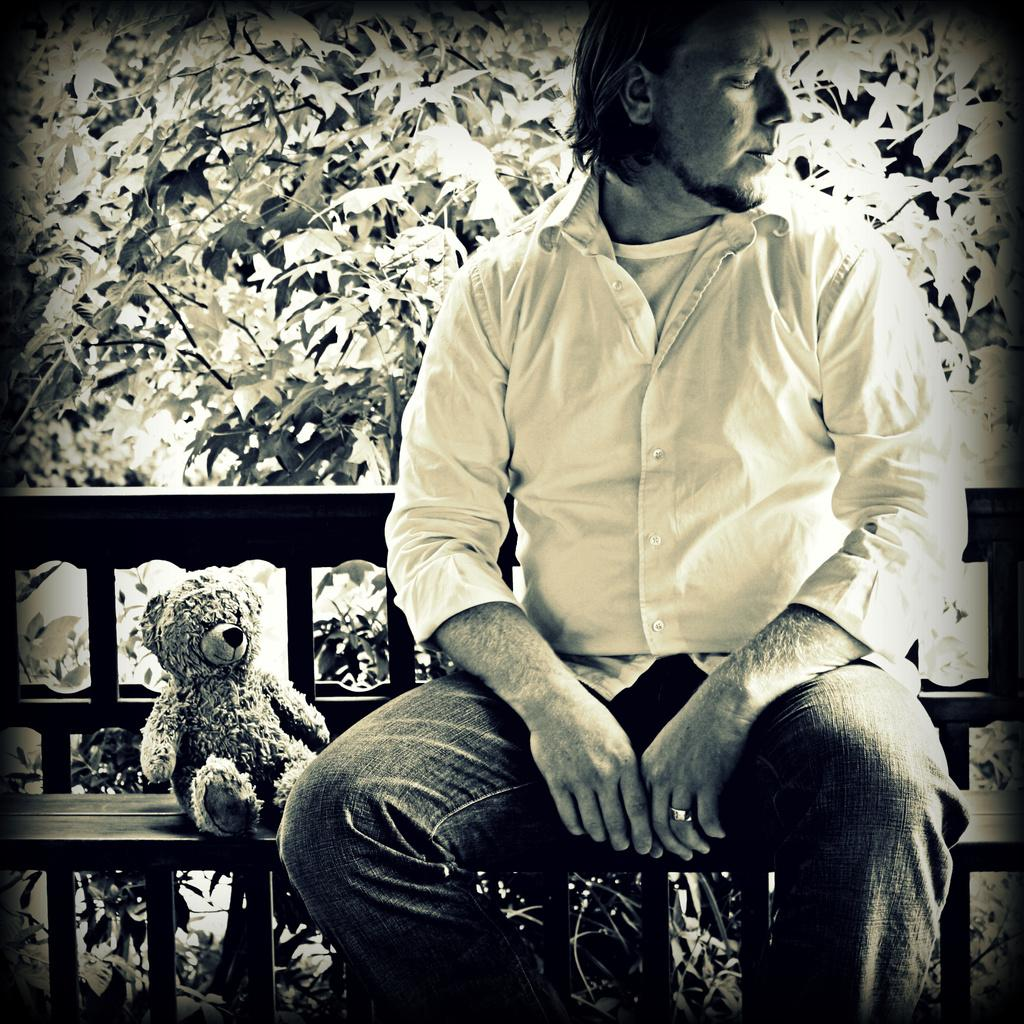What is the person in the image doing? The person is sitting on a bench in the image. What object is also present in the image? There is a teddy bear in the image. What can be seen in the background of the image? There are plants visible in the background of the image. What type of connection can be seen between the person and the toad in the image? There is no toad present in the image, so there is no connection between the person and a toad. 